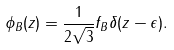Convert formula to latex. <formula><loc_0><loc_0><loc_500><loc_500>\phi _ { B } ( z ) = \frac { 1 } { 2 \sqrt { 3 } } f _ { B } \delta ( z - \epsilon ) .</formula> 